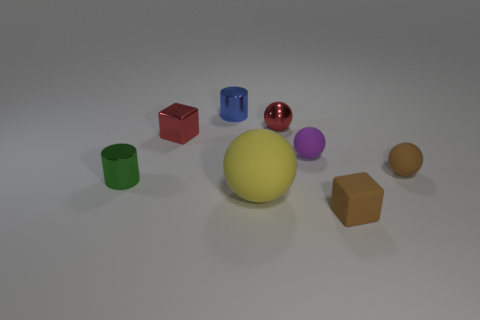Add 1 blue objects. How many objects exist? 9 Subtract all blocks. How many objects are left? 6 Add 7 large yellow rubber spheres. How many large yellow rubber spheres exist? 8 Subtract 1 green cylinders. How many objects are left? 7 Subtract all tiny brown matte blocks. Subtract all large matte things. How many objects are left? 6 Add 2 red spheres. How many red spheres are left? 3 